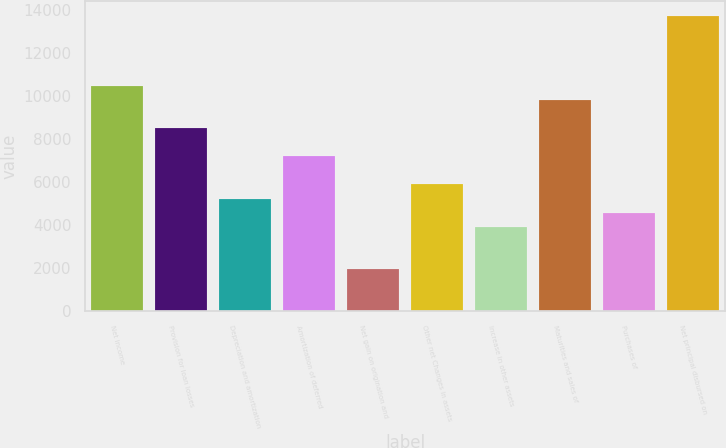Convert chart. <chart><loc_0><loc_0><loc_500><loc_500><bar_chart><fcel>Net income<fcel>Provision for loan losses<fcel>Depreciation and amortization<fcel>Amortization of deferred<fcel>Net gain on origination and<fcel>Other net Changes in assets<fcel>Increase in other assets<fcel>Maturities and sales of<fcel>Purchases of<fcel>Net principal disbursed on<nl><fcel>10478.6<fcel>8516.3<fcel>5245.8<fcel>7208.1<fcel>1975.3<fcel>5899.9<fcel>3937.6<fcel>9824.5<fcel>4591.7<fcel>13749.1<nl></chart> 